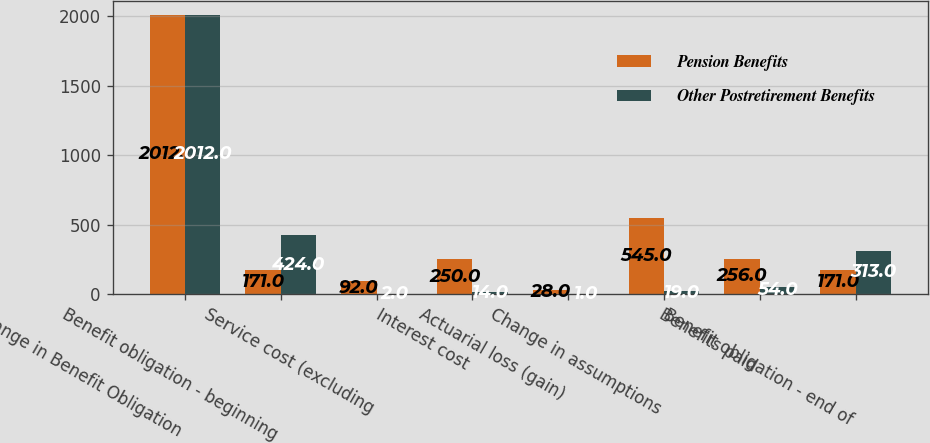Convert chart. <chart><loc_0><loc_0><loc_500><loc_500><stacked_bar_chart><ecel><fcel>Change in Benefit Obligation<fcel>Benefit obligation - beginning<fcel>Service cost (excluding<fcel>Interest cost<fcel>Actuarial loss (gain)<fcel>Change in assumptions<fcel>Benefits paid<fcel>Benefit obligation - end of<nl><fcel>Pension Benefits<fcel>2012<fcel>171<fcel>92<fcel>250<fcel>28<fcel>545<fcel>256<fcel>171<nl><fcel>Other Postretirement Benefits<fcel>2012<fcel>424<fcel>2<fcel>14<fcel>1<fcel>19<fcel>54<fcel>313<nl></chart> 